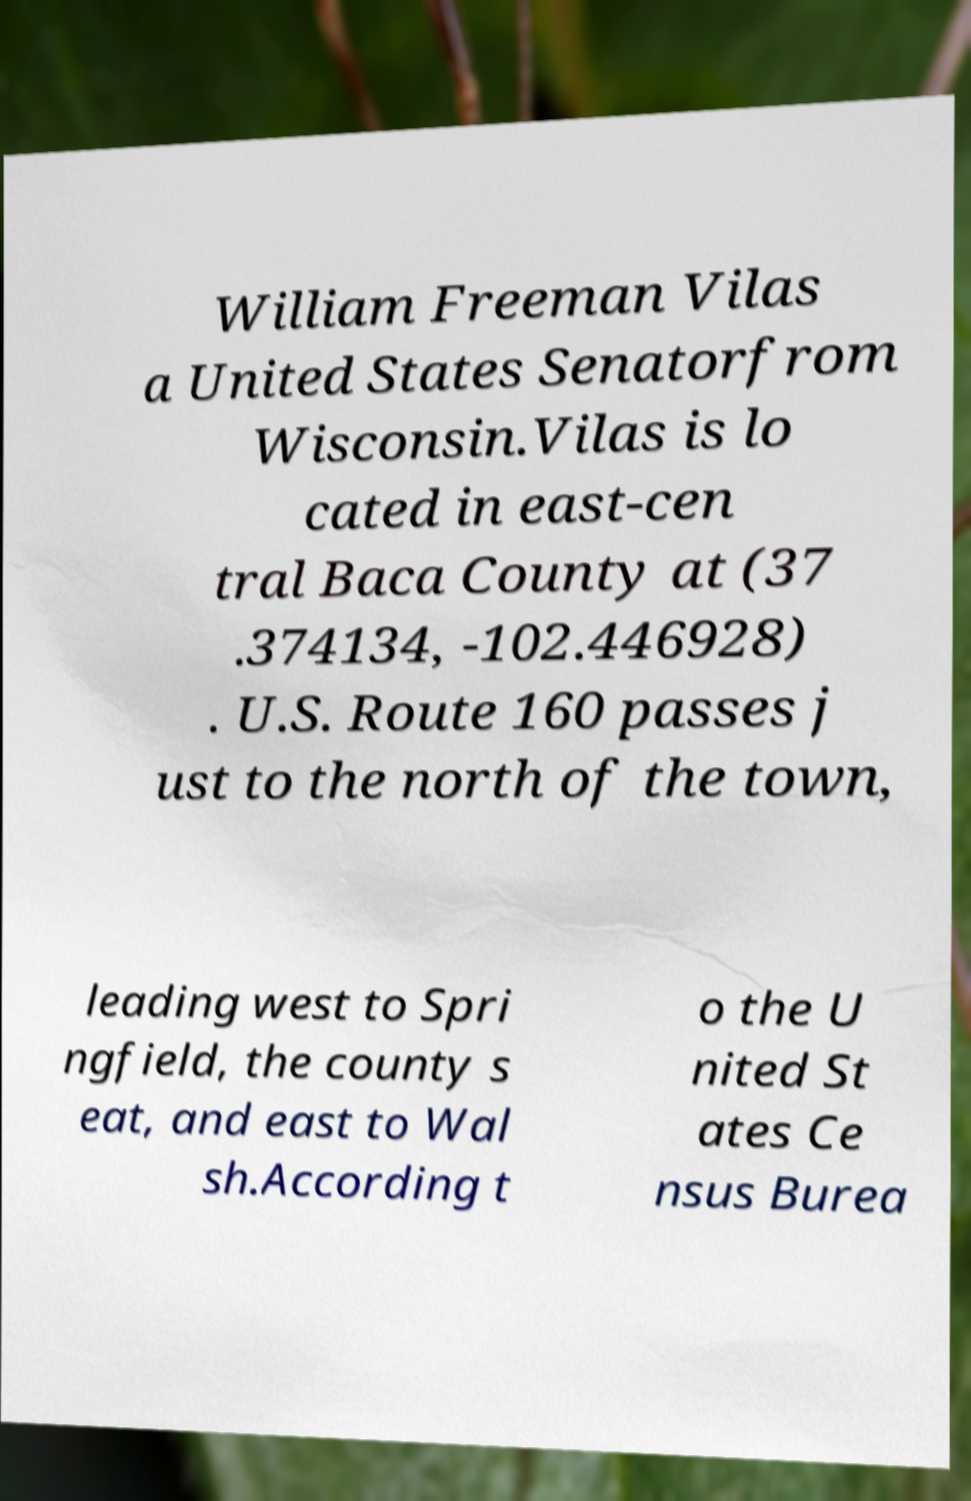For documentation purposes, I need the text within this image transcribed. Could you provide that? William Freeman Vilas a United States Senatorfrom Wisconsin.Vilas is lo cated in east-cen tral Baca County at (37 .374134, -102.446928) . U.S. Route 160 passes j ust to the north of the town, leading west to Spri ngfield, the county s eat, and east to Wal sh.According t o the U nited St ates Ce nsus Burea 